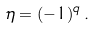Convert formula to latex. <formula><loc_0><loc_0><loc_500><loc_500>\eta = ( - 1 ) ^ { q } \, .</formula> 